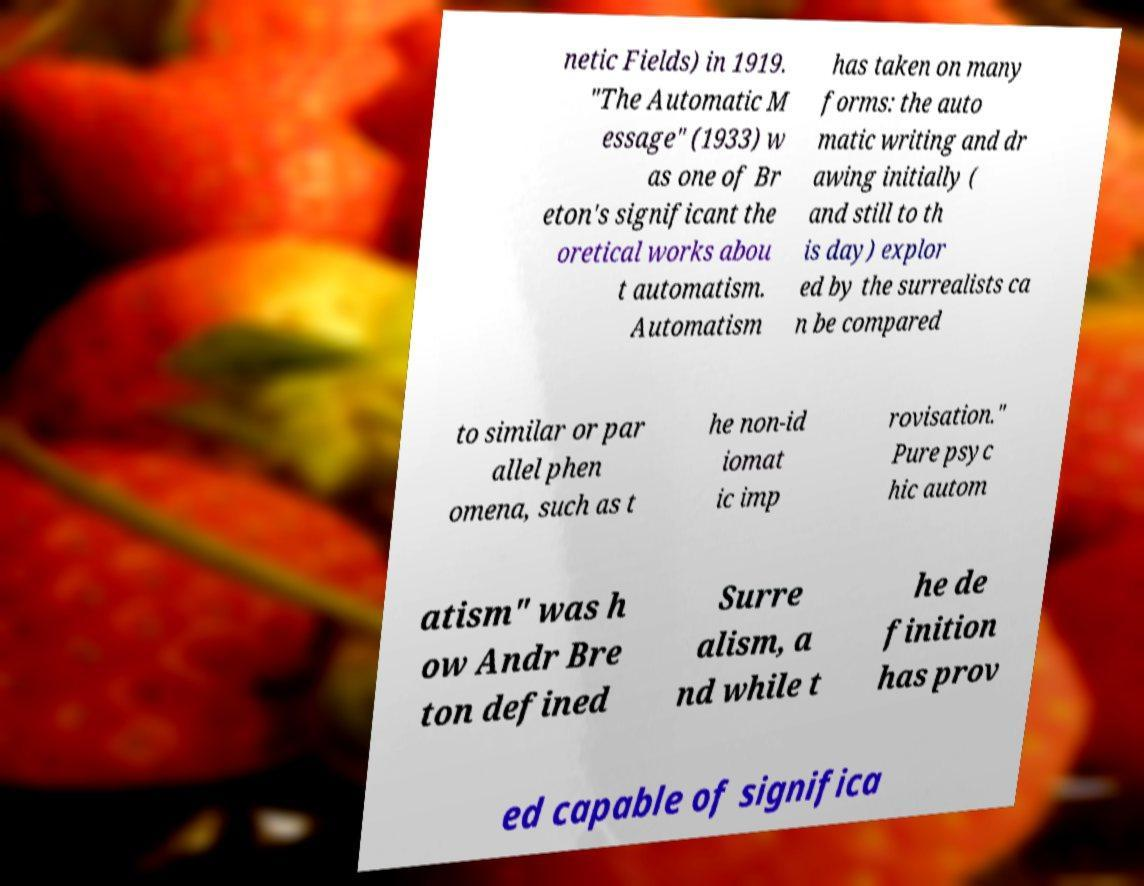Can you read and provide the text displayed in the image?This photo seems to have some interesting text. Can you extract and type it out for me? netic Fields) in 1919. "The Automatic M essage" (1933) w as one of Br eton's significant the oretical works abou t automatism. Automatism has taken on many forms: the auto matic writing and dr awing initially ( and still to th is day) explor ed by the surrealists ca n be compared to similar or par allel phen omena, such as t he non-id iomat ic imp rovisation." Pure psyc hic autom atism" was h ow Andr Bre ton defined Surre alism, a nd while t he de finition has prov ed capable of significa 